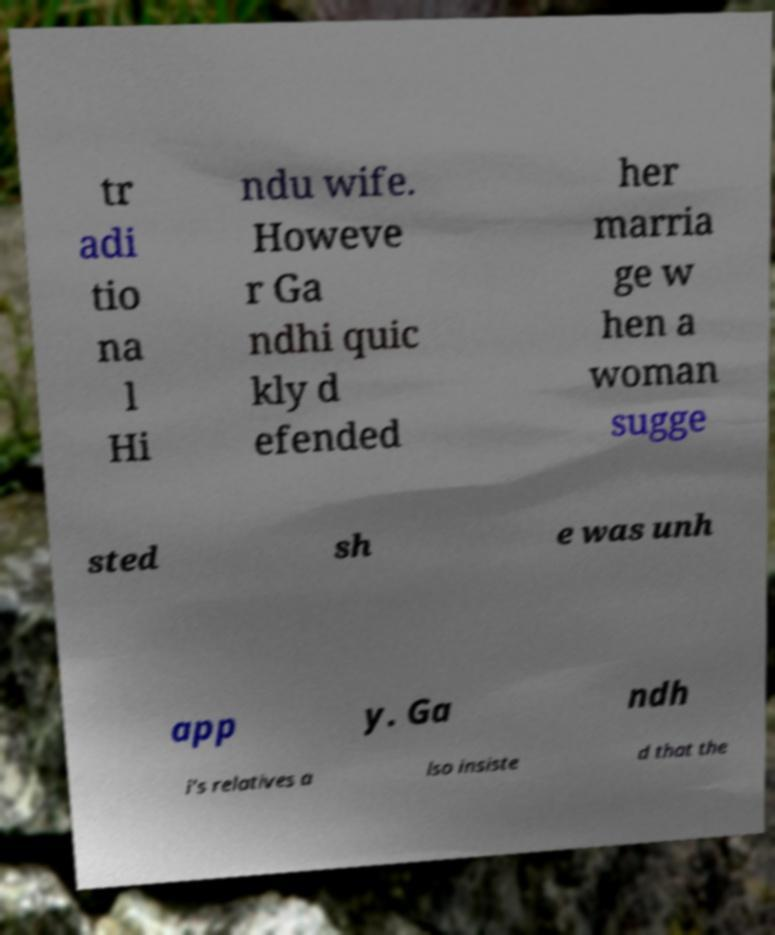Can you read and provide the text displayed in the image?This photo seems to have some interesting text. Can you extract and type it out for me? tr adi tio na l Hi ndu wife. Howeve r Ga ndhi quic kly d efended her marria ge w hen a woman sugge sted sh e was unh app y. Ga ndh i's relatives a lso insiste d that the 